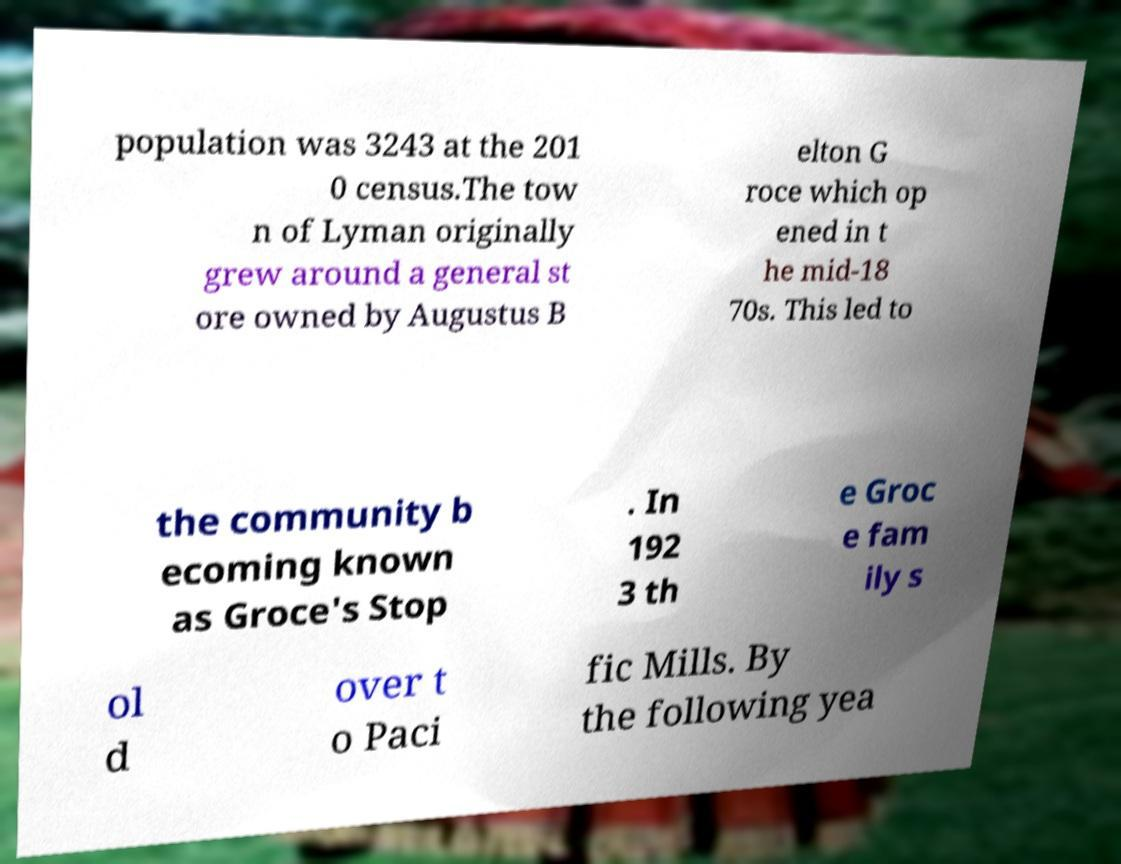Please read and relay the text visible in this image. What does it say? population was 3243 at the 201 0 census.The tow n of Lyman originally grew around a general st ore owned by Augustus B elton G roce which op ened in t he mid-18 70s. This led to the community b ecoming known as Groce's Stop . In 192 3 th e Groc e fam ily s ol d over t o Paci fic Mills. By the following yea 